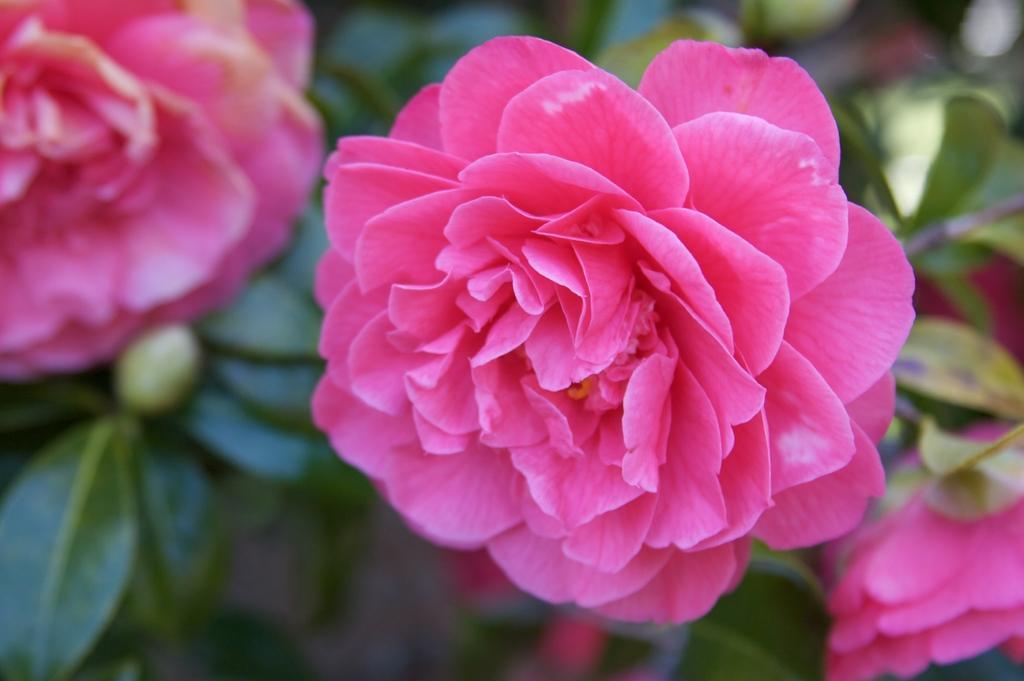Could you give a brief overview of what you see in this image? In the foreground of this image, there is a pink rose flower to the plants and on the bottom right corner and on the top left corner, there are rose flowers to the plant. 